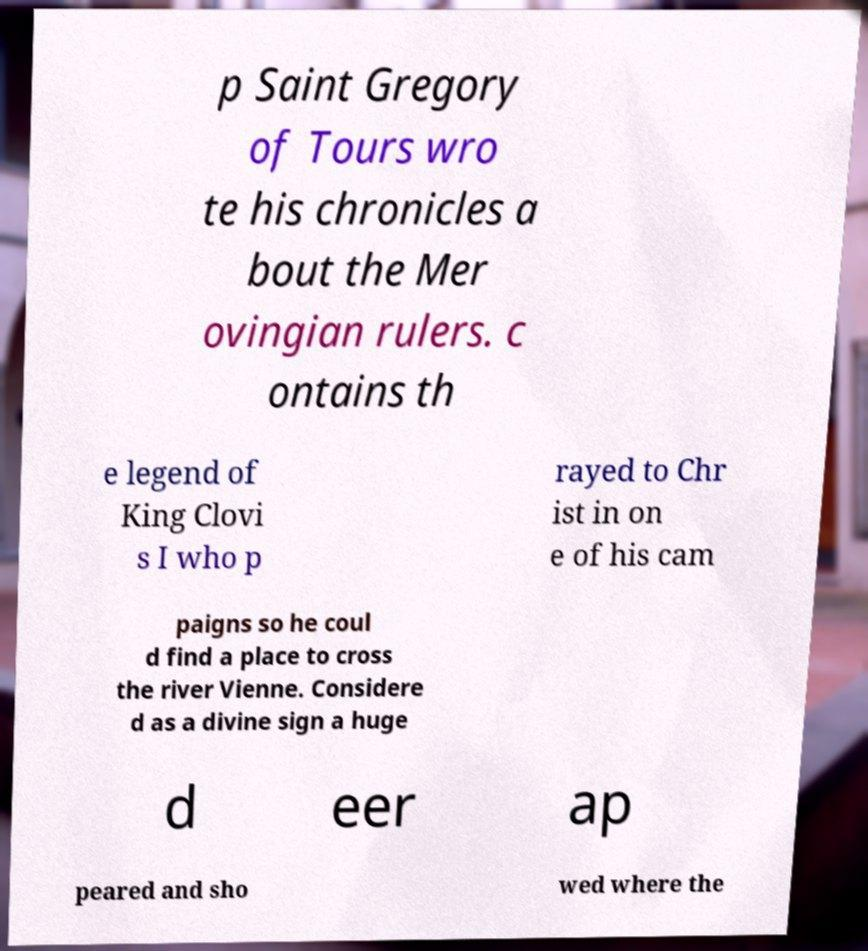Could you extract and type out the text from this image? p Saint Gregory of Tours wro te his chronicles a bout the Mer ovingian rulers. c ontains th e legend of King Clovi s I who p rayed to Chr ist in on e of his cam paigns so he coul d find a place to cross the river Vienne. Considere d as a divine sign a huge d eer ap peared and sho wed where the 